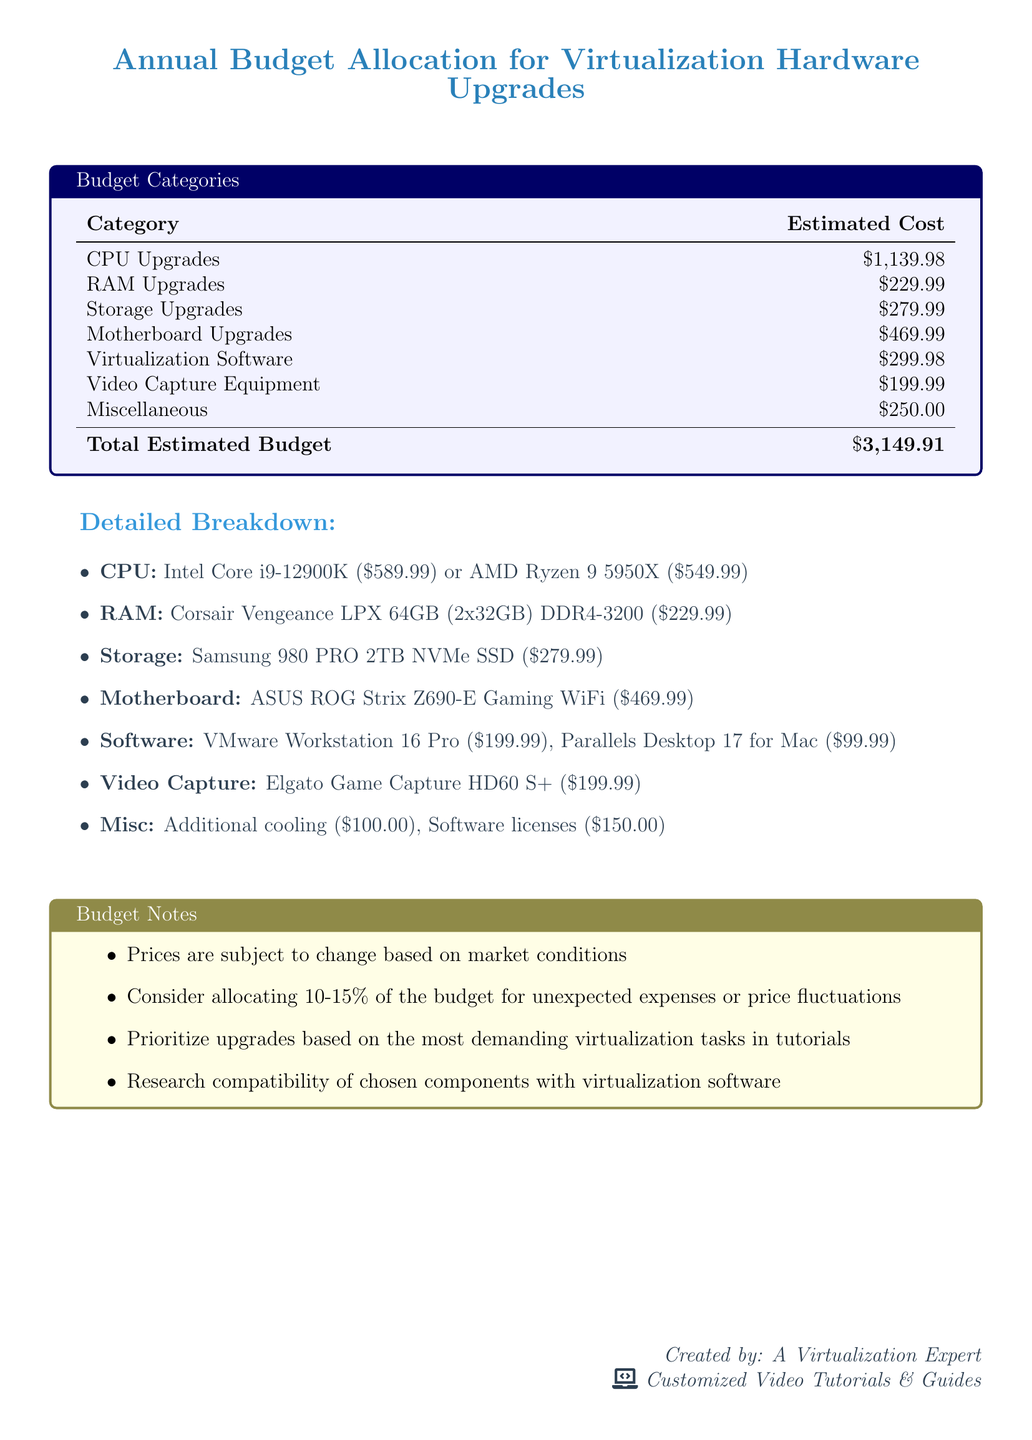What is the estimated cost for CPU upgrades? The estimated cost for CPU upgrades listed in the document is $1,139.98.
Answer: $1,139.98 What is the total estimated budget? The total estimated budget is the sum of all categories in the document, which is $3,149.91.
Answer: $3,149.91 How much is allocated for storage upgrades? The allocation for storage upgrades is provided in the table as $279.99.
Answer: $279.99 What is the price of VMware Workstation 16 Pro? The document lists the price of VMware Workstation 16 Pro as $199.99.
Answer: $199.99 Which motherboard is suggested in the document? The suggested motherboard mentioned in the document is ASUS ROG Strix Z690-E Gaming WiFi.
Answer: ASUS ROG Strix Z690-E Gaming WiFi What percentage of the budget is recommended for unexpected expenses? The document suggests allocating 10-15% of the budget for unexpected expenses.
Answer: 10-15% Which component has the lowest estimated cost? The component with the lowest estimated cost in the document is RAM upgrades at $229.99.
Answer: $229.99 What is one of the notes regarding the budget? One note regarding the budget emphasizes the importance of prioritizing upgrades based on demanding virtualization tasks.
Answer: Prioritize upgrades based on the most demanding virtualization tasks in tutorials How much is the Elgato Game Capture HD60 S+ priced at? The pricing for the Elgato Game Capture HD60 S+ in the document is stated as $199.99.
Answer: $199.99 What is the cost for miscellaneous items? The cost for miscellaneous items in the document is recorded as $250.00.
Answer: $250.00 